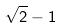<formula> <loc_0><loc_0><loc_500><loc_500>\sqrt { 2 } - 1</formula> 